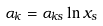Convert formula to latex. <formula><loc_0><loc_0><loc_500><loc_500>\alpha _ { k } = \alpha _ { k s } \ln x _ { s }</formula> 